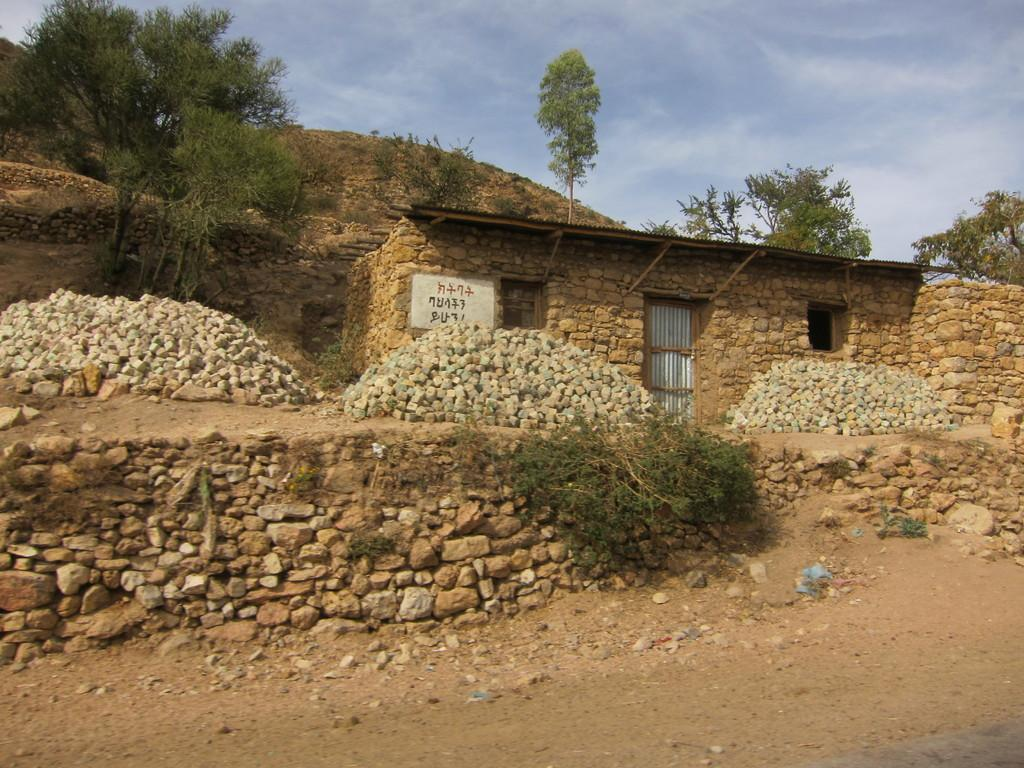What type of structure is in the image? There is a house in the image. What features can be seen on the house? The house has a window and a door. What type of terrain is depicted in the image? The image depicts a hill. What natural elements are present in the image? There are rocks, trees, and the sky visible in the image. What type of insect can be seen crawling on the face of the house in the image? There is no insect present in the image, nor is there a face on the house. 